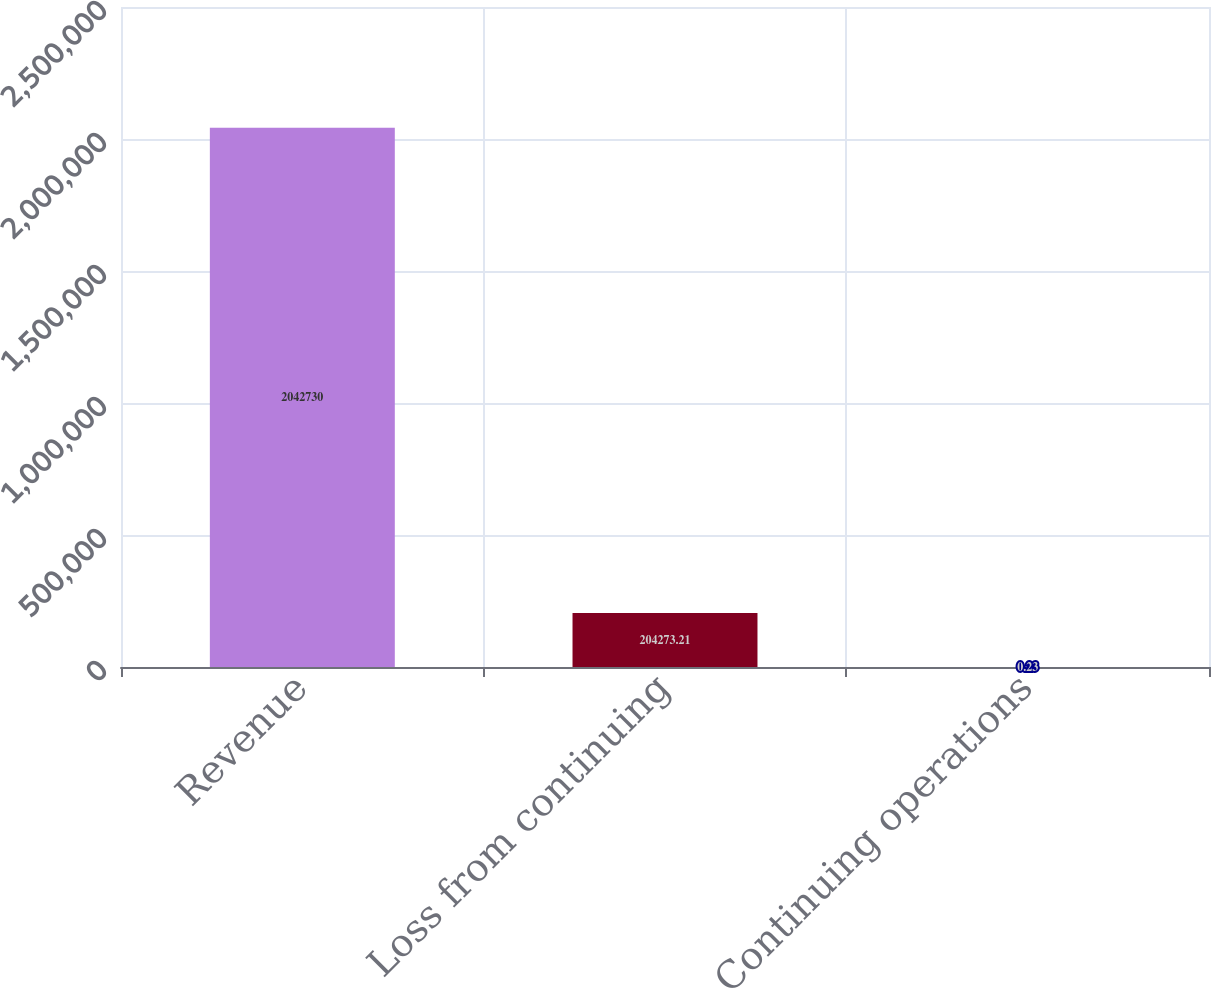Convert chart to OTSL. <chart><loc_0><loc_0><loc_500><loc_500><bar_chart><fcel>Revenue<fcel>Loss from continuing<fcel>Continuing operations<nl><fcel>2.04273e+06<fcel>204273<fcel>0.23<nl></chart> 